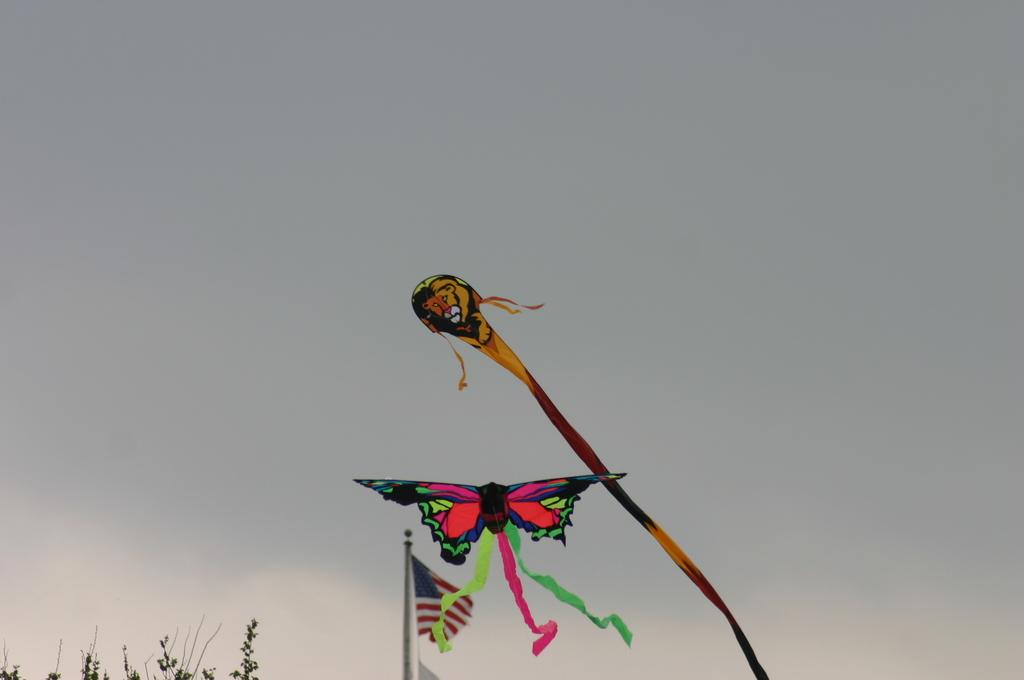What can be seen flying in the middle of the image? There are two kites in the middle of the image. What is located at the bottom of the image? There are leaves of a tree at the bottom of the image. What is visible in the background of the image? The sky is visible in the background of the image. How many people are participating in the feast in the image? There is no feast present in the image; it features a flag, leaves of a tree, two kites, and the sky. What type of trip can be seen in the image? There is no trip visible in the image; it primarily shows a flag, leaves of a tree, two kites, and the sky. 